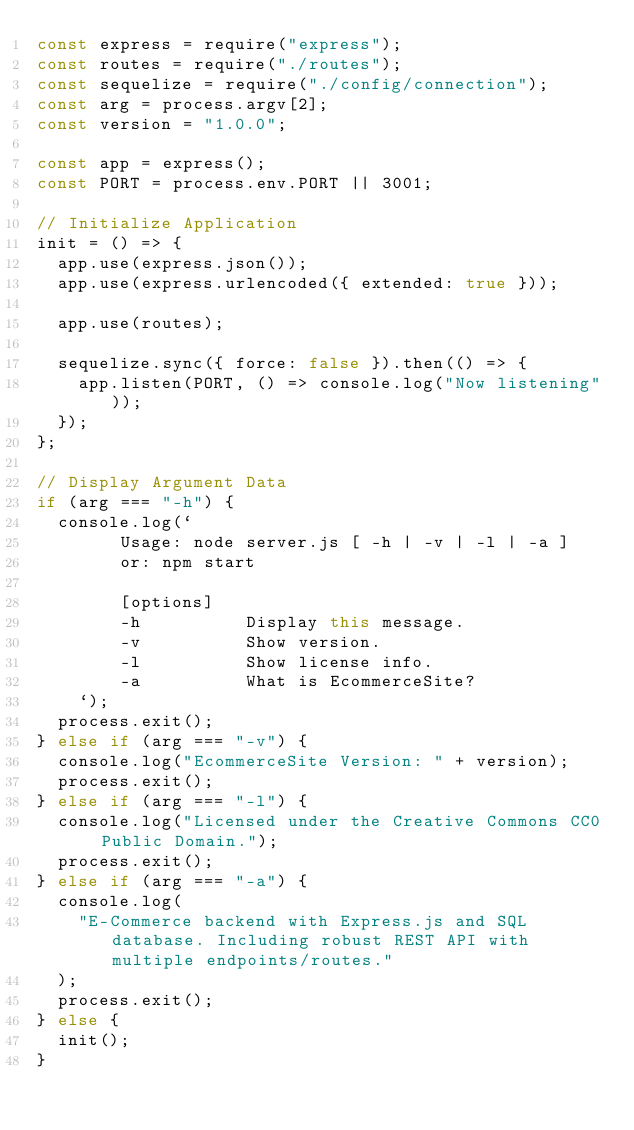Convert code to text. <code><loc_0><loc_0><loc_500><loc_500><_JavaScript_>const express = require("express");
const routes = require("./routes");
const sequelize = require("./config/connection");
const arg = process.argv[2];
const version = "1.0.0";

const app = express();
const PORT = process.env.PORT || 3001;

// Initialize Application
init = () => {
  app.use(express.json());
  app.use(express.urlencoded({ extended: true }));

  app.use(routes);

  sequelize.sync({ force: false }).then(() => {
    app.listen(PORT, () => console.log("Now listening"));
  });
};

// Display Argument Data
if (arg === "-h") {
  console.log(`
        Usage: node server.js [ -h | -v | -l | -a ]
        or: npm start
        
        [options]
        -h          Display this message.
        -v          Show version.
        -l          Show license info.
        -a          What is EcommerceSite?
    `);
  process.exit();
} else if (arg === "-v") {
  console.log("EcommerceSite Version: " + version);
  process.exit();
} else if (arg === "-l") {
  console.log("Licensed under the Creative Commons CC0 Public Domain.");
  process.exit();
} else if (arg === "-a") {
  console.log(
    "E-Commerce backend with Express.js and SQL database. Including robust REST API with multiple endpoints/routes."
  );
  process.exit();
} else {
  init();
}
</code> 